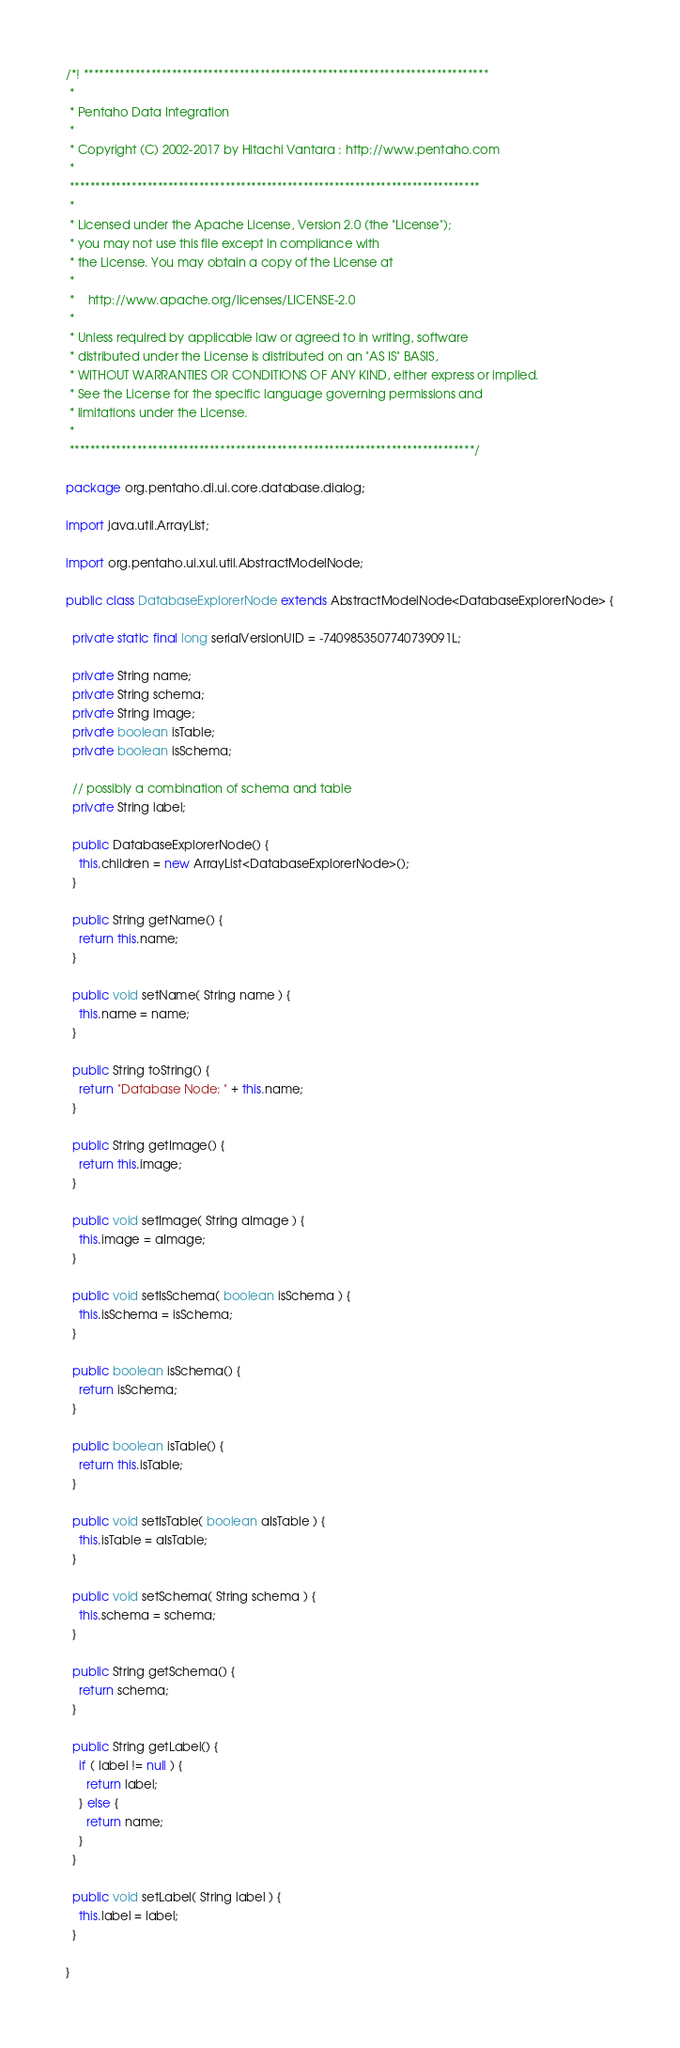<code> <loc_0><loc_0><loc_500><loc_500><_Java_>/*! ******************************************************************************
 *
 * Pentaho Data Integration
 *
 * Copyright (C) 2002-2017 by Hitachi Vantara : http://www.pentaho.com
 *
 *******************************************************************************
 *
 * Licensed under the Apache License, Version 2.0 (the "License");
 * you may not use this file except in compliance with
 * the License. You may obtain a copy of the License at
 *
 *    http://www.apache.org/licenses/LICENSE-2.0
 *
 * Unless required by applicable law or agreed to in writing, software
 * distributed under the License is distributed on an "AS IS" BASIS,
 * WITHOUT WARRANTIES OR CONDITIONS OF ANY KIND, either express or implied.
 * See the License for the specific language governing permissions and
 * limitations under the License.
 *
 ******************************************************************************/

package org.pentaho.di.ui.core.database.dialog;

import java.util.ArrayList;

import org.pentaho.ui.xul.util.AbstractModelNode;

public class DatabaseExplorerNode extends AbstractModelNode<DatabaseExplorerNode> {

  private static final long serialVersionUID = -7409853507740739091L;

  private String name;
  private String schema;
  private String image;
  private boolean isTable;
  private boolean isSchema;

  // possibly a combination of schema and table
  private String label;

  public DatabaseExplorerNode() {
    this.children = new ArrayList<DatabaseExplorerNode>();
  }

  public String getName() {
    return this.name;
  }

  public void setName( String name ) {
    this.name = name;
  }

  public String toString() {
    return "Database Node: " + this.name;
  }

  public String getImage() {
    return this.image;
  }

  public void setImage( String aImage ) {
    this.image = aImage;
  }

  public void setIsSchema( boolean isSchema ) {
    this.isSchema = isSchema;
  }

  public boolean isSchema() {
    return isSchema;
  }

  public boolean isTable() {
    return this.isTable;
  }

  public void setIsTable( boolean aIsTable ) {
    this.isTable = aIsTable;
  }

  public void setSchema( String schema ) {
    this.schema = schema;
  }

  public String getSchema() {
    return schema;
  }

  public String getLabel() {
    if ( label != null ) {
      return label;
    } else {
      return name;
    }
  }

  public void setLabel( String label ) {
    this.label = label;
  }

}
</code> 